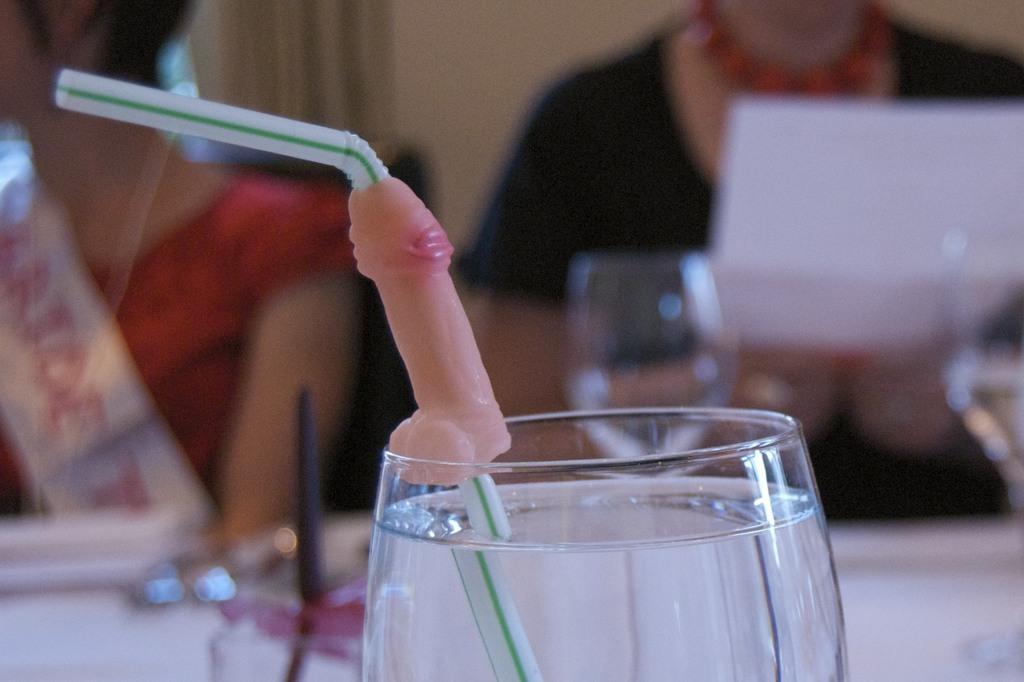Can you describe this image briefly? In this image there is a glass having a straw. The glass is filled with the drink. Behind there is a table having glasses and few objects. Right side there is a person holding a paper. Left side there is a woman. Background there is a wall. 